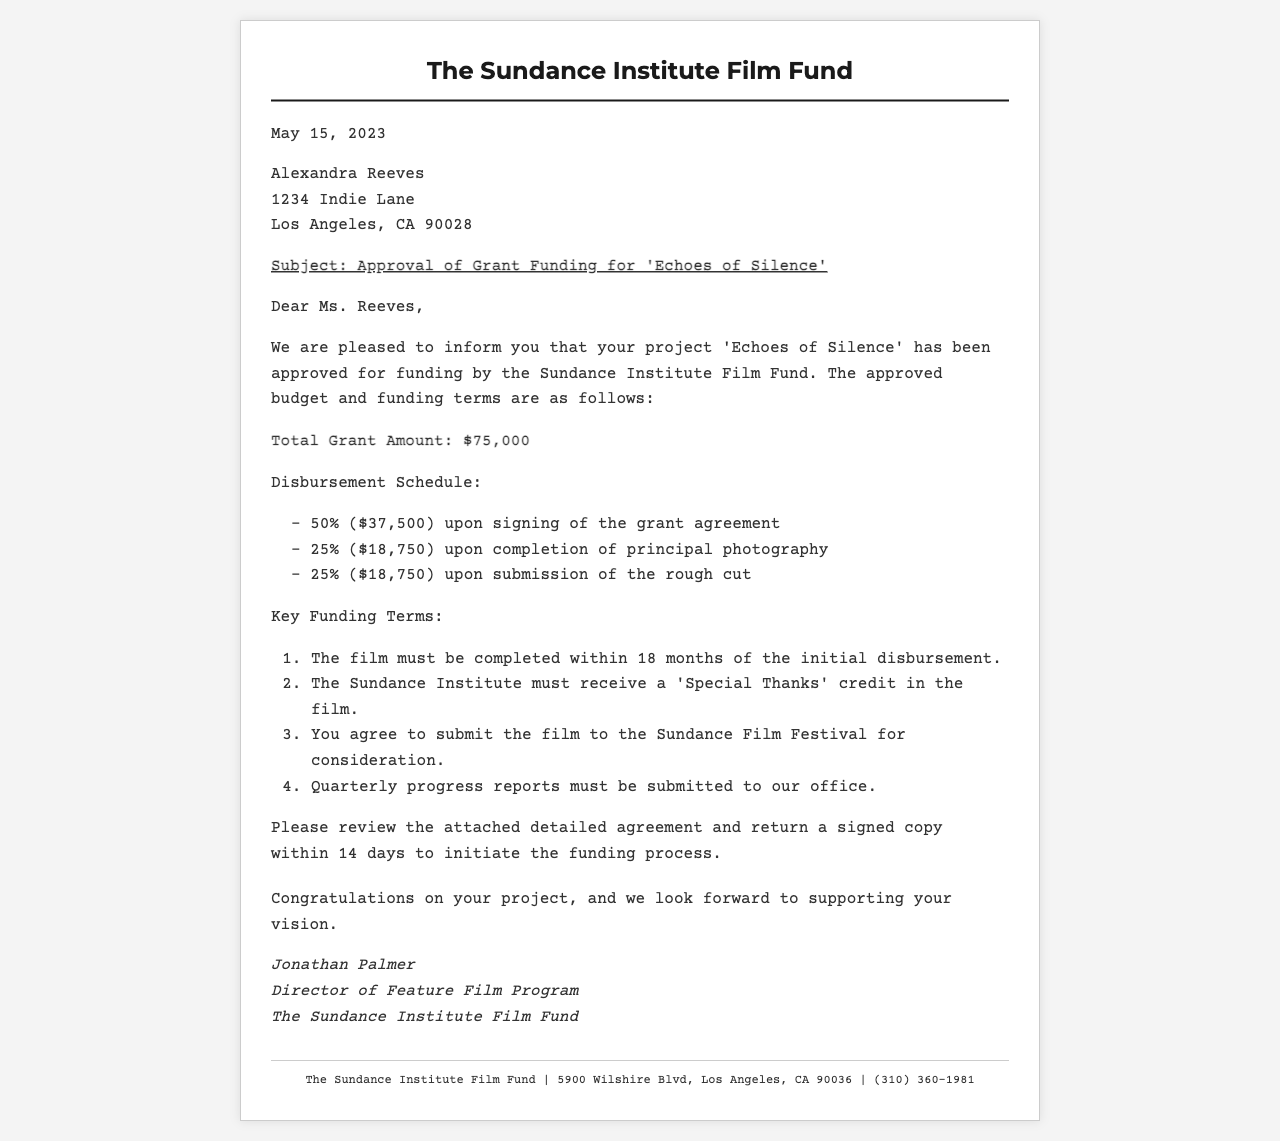What is the total grant amount? The total grant amount is explicitly stated in the document as $75,000.
Answer: $75,000 When is the date of the letter? The date the letter was written is mentioned at the top of the document as May 15, 2023.
Answer: May 15, 2023 Who is the recipient of the letter? The letter is addressed to Alexandra Reeves, who is specified in the recipient section.
Answer: Alexandra Reeves What percentage of the grant is disbursed upon signing? The document details that 50% of the grant, which is $37,500, is given upon signing.
Answer: 50% What must be included as a credit in the film? The key funding terms state that the Sundance Institute must receive a 'Special Thanks' credit in the film.
Answer: 'Special Thanks' How many months do I have to complete the film? The document mentions that the film must be completed within 18 months of the initial disbursement.
Answer: 18 months What is required to be submitted to the Sundance Film Festival? According to the key funding terms, you agree to submit the film to the Sundance Film Festival for consideration.
Answer: Submit the film Who is the author of the letter? The signature at the bottom of the letter indicates that it is authored by Jonathan Palmer.
Answer: Jonathan Palmer How many quarterly progress reports are required? The letter states that quarterly progress reports must be submitted, implying a total of four reports.
Answer: Four 